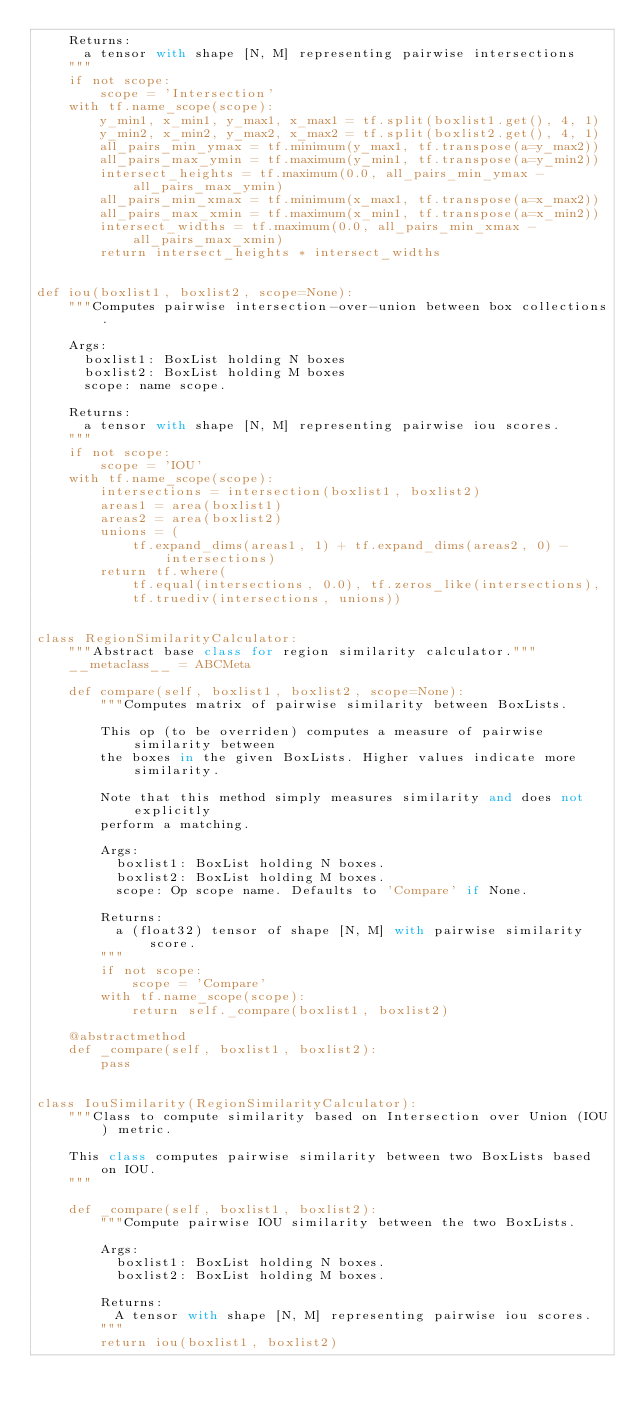Convert code to text. <code><loc_0><loc_0><loc_500><loc_500><_Python_>    Returns:
      a tensor with shape [N, M] representing pairwise intersections
    """
    if not scope:
        scope = 'Intersection'
    with tf.name_scope(scope):
        y_min1, x_min1, y_max1, x_max1 = tf.split(boxlist1.get(), 4, 1)
        y_min2, x_min2, y_max2, x_max2 = tf.split(boxlist2.get(), 4, 1)
        all_pairs_min_ymax = tf.minimum(y_max1, tf.transpose(a=y_max2))
        all_pairs_max_ymin = tf.maximum(y_min1, tf.transpose(a=y_min2))
        intersect_heights = tf.maximum(0.0, all_pairs_min_ymax - all_pairs_max_ymin)
        all_pairs_min_xmax = tf.minimum(x_max1, tf.transpose(a=x_max2))
        all_pairs_max_xmin = tf.maximum(x_min1, tf.transpose(a=x_min2))
        intersect_widths = tf.maximum(0.0, all_pairs_min_xmax - all_pairs_max_xmin)
        return intersect_heights * intersect_widths


def iou(boxlist1, boxlist2, scope=None):
    """Computes pairwise intersection-over-union between box collections.

    Args:
      boxlist1: BoxList holding N boxes
      boxlist2: BoxList holding M boxes
      scope: name scope.

    Returns:
      a tensor with shape [N, M] representing pairwise iou scores.
    """
    if not scope:
        scope = 'IOU'
    with tf.name_scope(scope):
        intersections = intersection(boxlist1, boxlist2)
        areas1 = area(boxlist1)
        areas2 = area(boxlist2)
        unions = (
            tf.expand_dims(areas1, 1) + tf.expand_dims(areas2, 0) - intersections)
        return tf.where(
            tf.equal(intersections, 0.0), tf.zeros_like(intersections),
            tf.truediv(intersections, unions))


class RegionSimilarityCalculator:
    """Abstract base class for region similarity calculator."""
    __metaclass__ = ABCMeta

    def compare(self, boxlist1, boxlist2, scope=None):
        """Computes matrix of pairwise similarity between BoxLists.

        This op (to be overriden) computes a measure of pairwise similarity between
        the boxes in the given BoxLists. Higher values indicate more similarity.

        Note that this method simply measures similarity and does not explicitly
        perform a matching.

        Args:
          boxlist1: BoxList holding N boxes.
          boxlist2: BoxList holding M boxes.
          scope: Op scope name. Defaults to 'Compare' if None.

        Returns:
          a (float32) tensor of shape [N, M] with pairwise similarity score.
        """
        if not scope:
            scope = 'Compare'
        with tf.name_scope(scope):
            return self._compare(boxlist1, boxlist2)

    @abstractmethod
    def _compare(self, boxlist1, boxlist2):
        pass


class IouSimilarity(RegionSimilarityCalculator):
    """Class to compute similarity based on Intersection over Union (IOU) metric.

    This class computes pairwise similarity between two BoxLists based on IOU.
    """

    def _compare(self, boxlist1, boxlist2):
        """Compute pairwise IOU similarity between the two BoxLists.

        Args:
          boxlist1: BoxList holding N boxes.
          boxlist2: BoxList holding M boxes.

        Returns:
          A tensor with shape [N, M] representing pairwise iou scores.
        """
        return iou(boxlist1, boxlist2)
</code> 